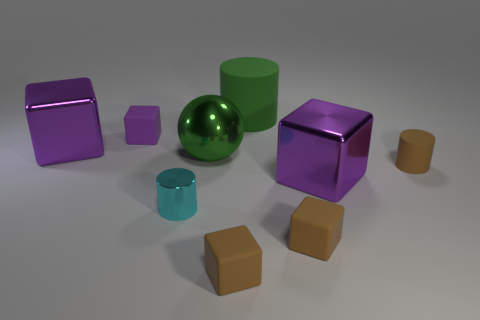Are there more big metallic blocks than purple rubber cubes?
Provide a succinct answer. Yes. What is the size of the other object that is the same color as the big rubber thing?
Make the answer very short. Large. Are there any small purple things that have the same material as the green ball?
Your answer should be very brief. No. What shape is the metallic thing that is both in front of the tiny matte cylinder and right of the cyan cylinder?
Your answer should be very brief. Cube. What number of other objects are there of the same shape as the tiny purple object?
Your answer should be very brief. 4. How big is the shiny cylinder?
Keep it short and to the point. Small. What number of objects are either large brown balls or small cubes?
Offer a very short reply. 3. There is a metallic object that is left of the cyan cylinder; what is its size?
Your answer should be compact. Large. Is there any other thing that is the same size as the purple matte block?
Make the answer very short. Yes. What is the color of the matte cube that is on the left side of the big green rubber thing and in front of the tiny metallic thing?
Provide a succinct answer. Brown. 